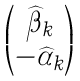<formula> <loc_0><loc_0><loc_500><loc_500>\begin{pmatrix} { \widehat { \beta } } _ { k } \\ - { \widehat { \alpha } } _ { k } \end{pmatrix}</formula> 